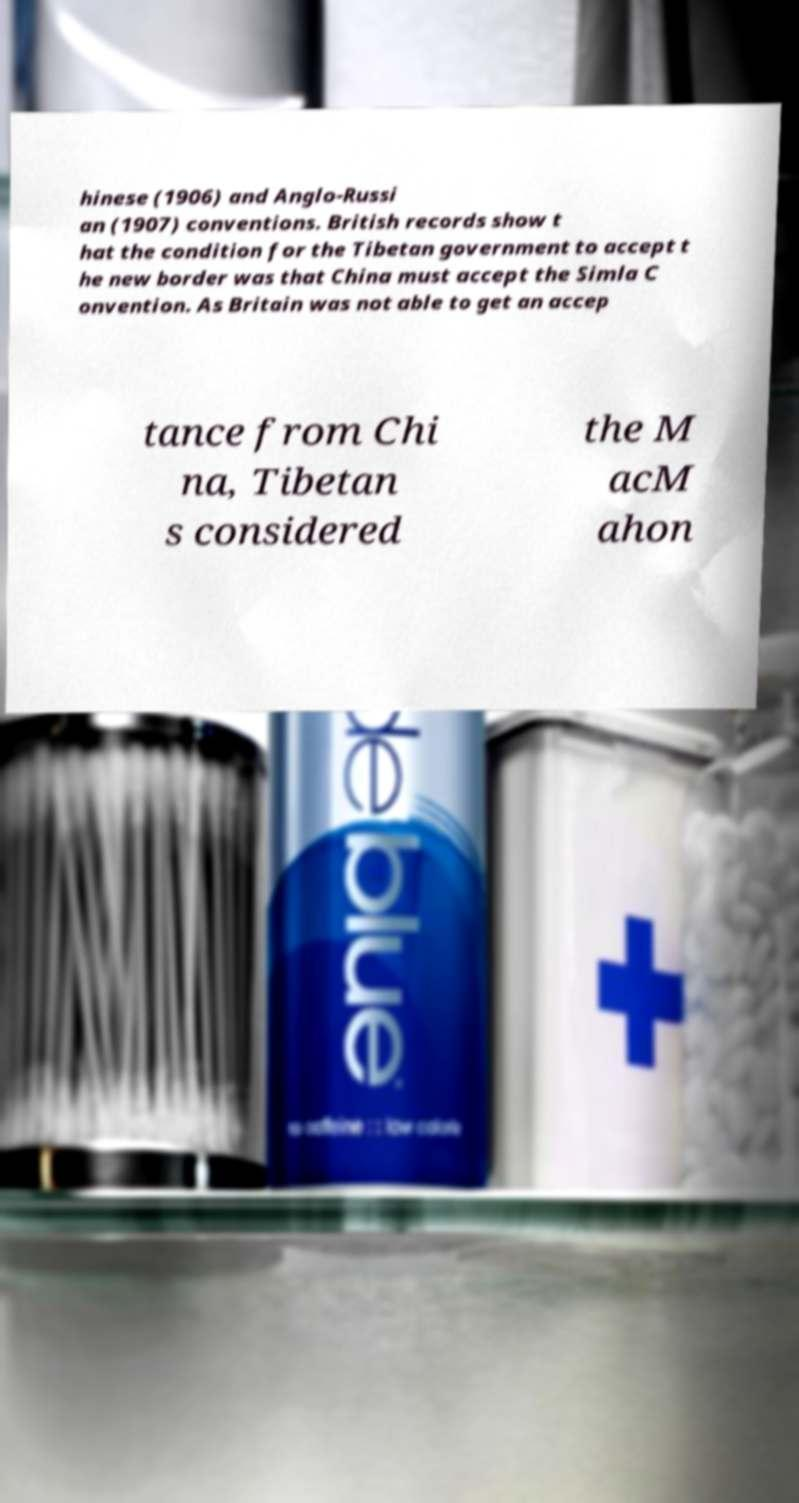Can you read and provide the text displayed in the image?This photo seems to have some interesting text. Can you extract and type it out for me? hinese (1906) and Anglo-Russi an (1907) conventions. British records show t hat the condition for the Tibetan government to accept t he new border was that China must accept the Simla C onvention. As Britain was not able to get an accep tance from Chi na, Tibetan s considered the M acM ahon 